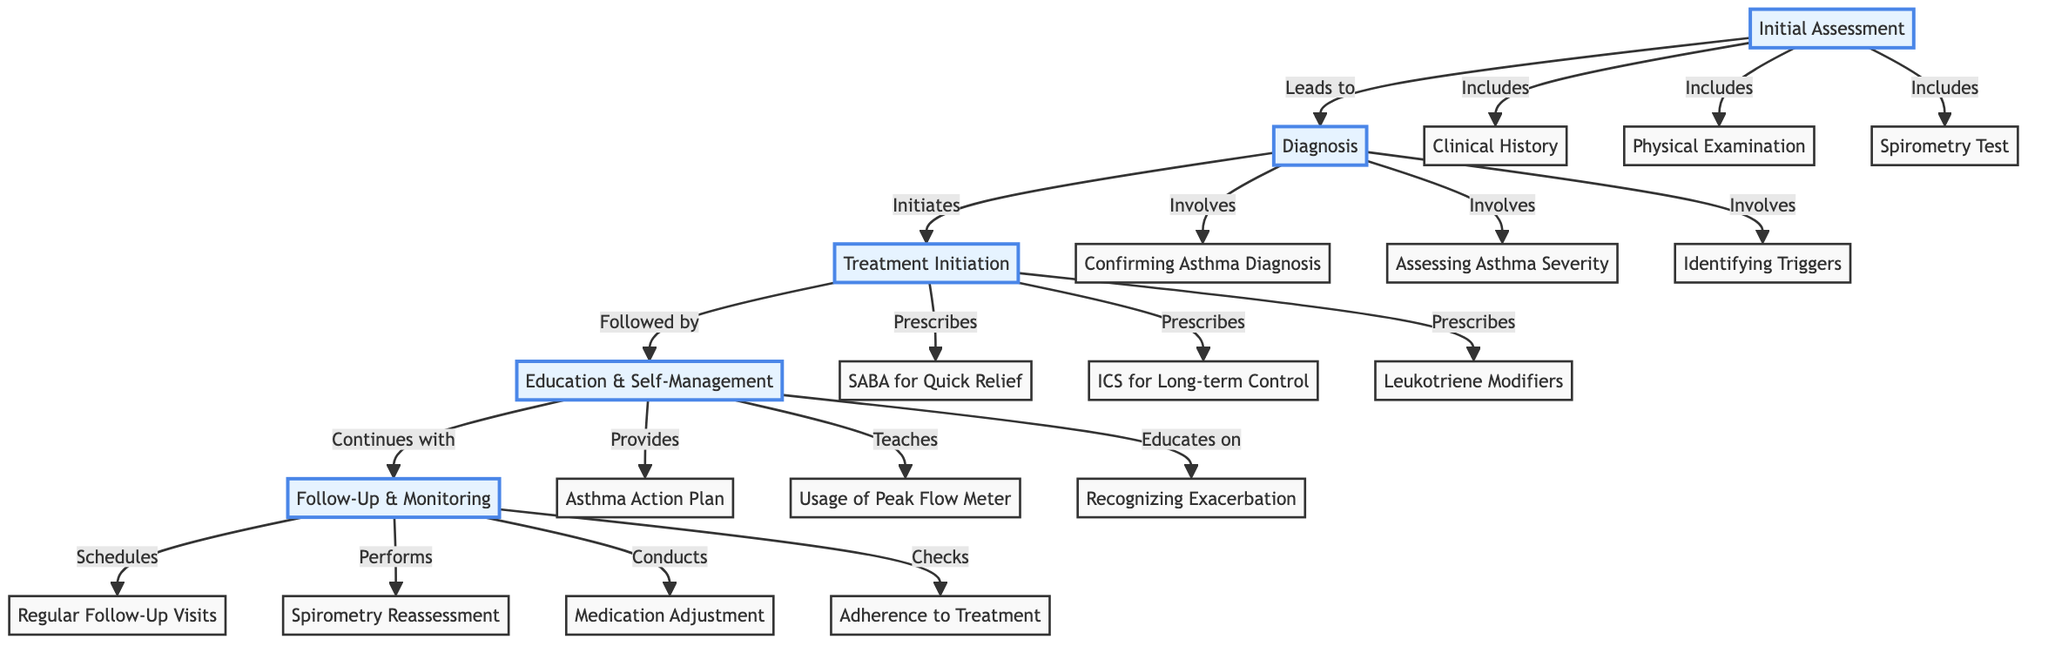What is the first step in the Pediatric Asthma Management Protocol? The diagram indicates that the first step is labeled as "Initial Assessment".
Answer: Initial Assessment How many details are included in the Initial Assessment step? The "Initial Assessment" step has three specific details: Clinical History, Physical Examination, and Spirometry Test. Hence, the count is three.
Answer: 3 What does the Diagnosis step involve? According to the diagram, the Diagnosis step involves three aspects: Confirming Asthma Diagnosis, Assessing Asthma Severity, and Identifying Triggers.
Answer: Confirming Asthma Diagnosis, Assessing Asthma Severity, Identifying Triggers Which step follows Treatment Initiation? The flowchart specifies that "Education & Self-Management" is the step that follows "Treatment Initiation".
Answer: Education & Self-Management What type of medication is prescribed for quick relief? The diagram states that a "Short-Acting Beta Agonist (SABA)" is prescribed for quick relief during the Treatment Initiation step.
Answer: Short-Acting Beta Agonist (SABA) What is the relationship between Follow-Up & Monitoring and Regular Follow-Up Visits? "Regular Follow-Up Visits" is a detail listed under Follow-Up & Monitoring, indicating that it is one of the procedures conducted during this step.
Answer: Schedules What is the last step in the management protocol? The diagram indicates that the last step in the Pediatric Asthma Management Protocol is "Follow-Up & Monitoring".
Answer: Follow-Up & Monitoring How many prescriptions are outlined in the Treatment Initiation step? There are three prescriptions cited in the Treatment Initiation step: SABA for Quick Relief, ICS for Long-term Control, and Leukotriene Modifiers. Therefore, the total is three.
Answer: 3 What action does Education & Self-Management provide? The Education & Self-Management step provides an "Asthma Action Plan" to help manage the condition.
Answer: Asthma Action Plan 